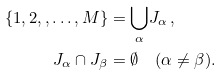<formula> <loc_0><loc_0><loc_500><loc_500>\{ 1 , 2 , , \dots , M \} & = { \bigcup _ { \alpha } } J _ { \alpha } \, , \\ J _ { \alpha } \cap J _ { \beta } & = \emptyset \quad ( \alpha \neq \beta ) .</formula> 